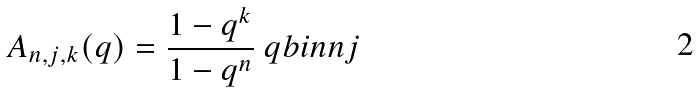Convert formula to latex. <formula><loc_0><loc_0><loc_500><loc_500>A _ { n , j , k } ( q ) = \frac { 1 - q ^ { k } } { 1 - q ^ { n } } \ q b i n { n } { j }</formula> 